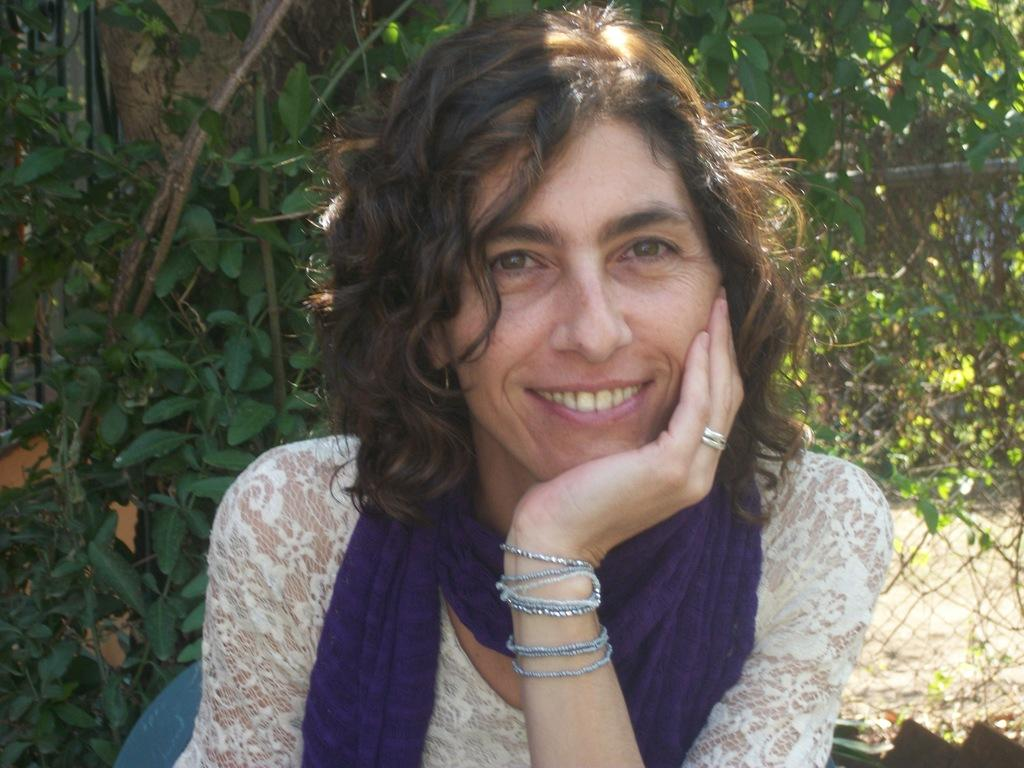Who is present in the image? There is a woman in the image. What is the woman doing in the image? The woman is sitting on a chair. What can be seen in the background of the image? There are trees in the background of the image. What type of noise can be heard coming from the lizards in the image? There are no lizards present in the image, so it is not possible to determine what noise, if any, might be heard from them. 